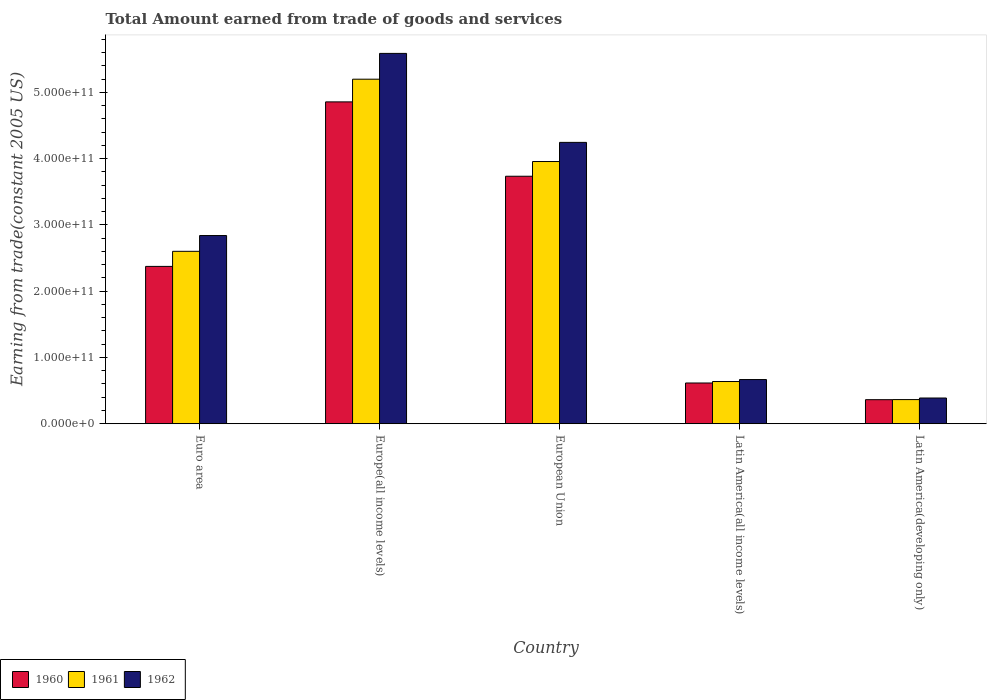How many different coloured bars are there?
Provide a short and direct response. 3. How many groups of bars are there?
Ensure brevity in your answer.  5. Are the number of bars on each tick of the X-axis equal?
Offer a very short reply. Yes. What is the label of the 4th group of bars from the left?
Your answer should be compact. Latin America(all income levels). In how many cases, is the number of bars for a given country not equal to the number of legend labels?
Ensure brevity in your answer.  0. What is the total amount earned by trading goods and services in 1962 in Europe(all income levels)?
Ensure brevity in your answer.  5.59e+11. Across all countries, what is the maximum total amount earned by trading goods and services in 1960?
Provide a short and direct response. 4.86e+11. Across all countries, what is the minimum total amount earned by trading goods and services in 1961?
Provide a short and direct response. 3.64e+1. In which country was the total amount earned by trading goods and services in 1962 maximum?
Give a very brief answer. Europe(all income levels). In which country was the total amount earned by trading goods and services in 1962 minimum?
Keep it short and to the point. Latin America(developing only). What is the total total amount earned by trading goods and services in 1962 in the graph?
Offer a very short reply. 1.37e+12. What is the difference between the total amount earned by trading goods and services in 1961 in Latin America(all income levels) and that in Latin America(developing only)?
Keep it short and to the point. 2.72e+1. What is the difference between the total amount earned by trading goods and services in 1961 in Euro area and the total amount earned by trading goods and services in 1962 in European Union?
Offer a very short reply. -1.64e+11. What is the average total amount earned by trading goods and services in 1962 per country?
Provide a succinct answer. 2.75e+11. What is the difference between the total amount earned by trading goods and services of/in 1961 and total amount earned by trading goods and services of/in 1960 in Latin America(all income levels)?
Keep it short and to the point. 2.22e+09. In how many countries, is the total amount earned by trading goods and services in 1962 greater than 180000000000 US$?
Give a very brief answer. 3. What is the ratio of the total amount earned by trading goods and services in 1962 in Euro area to that in Europe(all income levels)?
Offer a terse response. 0.51. What is the difference between the highest and the second highest total amount earned by trading goods and services in 1962?
Offer a terse response. 1.34e+11. What is the difference between the highest and the lowest total amount earned by trading goods and services in 1961?
Ensure brevity in your answer.  4.83e+11. In how many countries, is the total amount earned by trading goods and services in 1960 greater than the average total amount earned by trading goods and services in 1960 taken over all countries?
Your answer should be very brief. 2. How many bars are there?
Your answer should be very brief. 15. How many countries are there in the graph?
Ensure brevity in your answer.  5. What is the difference between two consecutive major ticks on the Y-axis?
Your answer should be compact. 1.00e+11. Are the values on the major ticks of Y-axis written in scientific E-notation?
Your response must be concise. Yes. Does the graph contain any zero values?
Keep it short and to the point. No. Does the graph contain grids?
Ensure brevity in your answer.  No. Where does the legend appear in the graph?
Keep it short and to the point. Bottom left. How are the legend labels stacked?
Keep it short and to the point. Horizontal. What is the title of the graph?
Keep it short and to the point. Total Amount earned from trade of goods and services. Does "1966" appear as one of the legend labels in the graph?
Provide a short and direct response. No. What is the label or title of the X-axis?
Offer a very short reply. Country. What is the label or title of the Y-axis?
Offer a terse response. Earning from trade(constant 2005 US). What is the Earning from trade(constant 2005 US) in 1960 in Euro area?
Ensure brevity in your answer.  2.37e+11. What is the Earning from trade(constant 2005 US) in 1961 in Euro area?
Your answer should be compact. 2.60e+11. What is the Earning from trade(constant 2005 US) in 1962 in Euro area?
Your answer should be compact. 2.84e+11. What is the Earning from trade(constant 2005 US) in 1960 in Europe(all income levels)?
Make the answer very short. 4.86e+11. What is the Earning from trade(constant 2005 US) of 1961 in Europe(all income levels)?
Ensure brevity in your answer.  5.20e+11. What is the Earning from trade(constant 2005 US) in 1962 in Europe(all income levels)?
Keep it short and to the point. 5.59e+11. What is the Earning from trade(constant 2005 US) in 1960 in European Union?
Your response must be concise. 3.73e+11. What is the Earning from trade(constant 2005 US) in 1961 in European Union?
Offer a terse response. 3.96e+11. What is the Earning from trade(constant 2005 US) of 1962 in European Union?
Offer a terse response. 4.24e+11. What is the Earning from trade(constant 2005 US) in 1960 in Latin America(all income levels)?
Ensure brevity in your answer.  6.15e+1. What is the Earning from trade(constant 2005 US) in 1961 in Latin America(all income levels)?
Offer a very short reply. 6.37e+1. What is the Earning from trade(constant 2005 US) of 1962 in Latin America(all income levels)?
Ensure brevity in your answer.  6.67e+1. What is the Earning from trade(constant 2005 US) in 1960 in Latin America(developing only)?
Your answer should be compact. 3.63e+1. What is the Earning from trade(constant 2005 US) of 1961 in Latin America(developing only)?
Provide a succinct answer. 3.64e+1. What is the Earning from trade(constant 2005 US) of 1962 in Latin America(developing only)?
Your response must be concise. 3.88e+1. Across all countries, what is the maximum Earning from trade(constant 2005 US) in 1960?
Provide a short and direct response. 4.86e+11. Across all countries, what is the maximum Earning from trade(constant 2005 US) of 1961?
Your answer should be very brief. 5.20e+11. Across all countries, what is the maximum Earning from trade(constant 2005 US) of 1962?
Your answer should be very brief. 5.59e+11. Across all countries, what is the minimum Earning from trade(constant 2005 US) of 1960?
Give a very brief answer. 3.63e+1. Across all countries, what is the minimum Earning from trade(constant 2005 US) in 1961?
Provide a succinct answer. 3.64e+1. Across all countries, what is the minimum Earning from trade(constant 2005 US) in 1962?
Your answer should be compact. 3.88e+1. What is the total Earning from trade(constant 2005 US) in 1960 in the graph?
Offer a very short reply. 1.19e+12. What is the total Earning from trade(constant 2005 US) of 1961 in the graph?
Give a very brief answer. 1.28e+12. What is the total Earning from trade(constant 2005 US) of 1962 in the graph?
Your answer should be compact. 1.37e+12. What is the difference between the Earning from trade(constant 2005 US) of 1960 in Euro area and that in Europe(all income levels)?
Your answer should be very brief. -2.48e+11. What is the difference between the Earning from trade(constant 2005 US) in 1961 in Euro area and that in Europe(all income levels)?
Your answer should be very brief. -2.60e+11. What is the difference between the Earning from trade(constant 2005 US) in 1962 in Euro area and that in Europe(all income levels)?
Offer a terse response. -2.75e+11. What is the difference between the Earning from trade(constant 2005 US) in 1960 in Euro area and that in European Union?
Keep it short and to the point. -1.36e+11. What is the difference between the Earning from trade(constant 2005 US) in 1961 in Euro area and that in European Union?
Ensure brevity in your answer.  -1.35e+11. What is the difference between the Earning from trade(constant 2005 US) in 1962 in Euro area and that in European Union?
Your answer should be very brief. -1.41e+11. What is the difference between the Earning from trade(constant 2005 US) in 1960 in Euro area and that in Latin America(all income levels)?
Your answer should be compact. 1.76e+11. What is the difference between the Earning from trade(constant 2005 US) of 1961 in Euro area and that in Latin America(all income levels)?
Your answer should be compact. 1.96e+11. What is the difference between the Earning from trade(constant 2005 US) of 1962 in Euro area and that in Latin America(all income levels)?
Provide a short and direct response. 2.17e+11. What is the difference between the Earning from trade(constant 2005 US) in 1960 in Euro area and that in Latin America(developing only)?
Offer a terse response. 2.01e+11. What is the difference between the Earning from trade(constant 2005 US) in 1961 in Euro area and that in Latin America(developing only)?
Provide a succinct answer. 2.24e+11. What is the difference between the Earning from trade(constant 2005 US) in 1962 in Euro area and that in Latin America(developing only)?
Your answer should be compact. 2.45e+11. What is the difference between the Earning from trade(constant 2005 US) of 1960 in Europe(all income levels) and that in European Union?
Your answer should be compact. 1.12e+11. What is the difference between the Earning from trade(constant 2005 US) of 1961 in Europe(all income levels) and that in European Union?
Keep it short and to the point. 1.24e+11. What is the difference between the Earning from trade(constant 2005 US) of 1962 in Europe(all income levels) and that in European Union?
Provide a succinct answer. 1.34e+11. What is the difference between the Earning from trade(constant 2005 US) of 1960 in Europe(all income levels) and that in Latin America(all income levels)?
Make the answer very short. 4.24e+11. What is the difference between the Earning from trade(constant 2005 US) in 1961 in Europe(all income levels) and that in Latin America(all income levels)?
Offer a terse response. 4.56e+11. What is the difference between the Earning from trade(constant 2005 US) of 1962 in Europe(all income levels) and that in Latin America(all income levels)?
Offer a very short reply. 4.92e+11. What is the difference between the Earning from trade(constant 2005 US) of 1960 in Europe(all income levels) and that in Latin America(developing only)?
Offer a terse response. 4.49e+11. What is the difference between the Earning from trade(constant 2005 US) in 1961 in Europe(all income levels) and that in Latin America(developing only)?
Offer a very short reply. 4.83e+11. What is the difference between the Earning from trade(constant 2005 US) in 1962 in Europe(all income levels) and that in Latin America(developing only)?
Provide a short and direct response. 5.20e+11. What is the difference between the Earning from trade(constant 2005 US) of 1960 in European Union and that in Latin America(all income levels)?
Offer a terse response. 3.12e+11. What is the difference between the Earning from trade(constant 2005 US) of 1961 in European Union and that in Latin America(all income levels)?
Your response must be concise. 3.32e+11. What is the difference between the Earning from trade(constant 2005 US) in 1962 in European Union and that in Latin America(all income levels)?
Your answer should be compact. 3.58e+11. What is the difference between the Earning from trade(constant 2005 US) in 1960 in European Union and that in Latin America(developing only)?
Give a very brief answer. 3.37e+11. What is the difference between the Earning from trade(constant 2005 US) of 1961 in European Union and that in Latin America(developing only)?
Your response must be concise. 3.59e+11. What is the difference between the Earning from trade(constant 2005 US) of 1962 in European Union and that in Latin America(developing only)?
Provide a succinct answer. 3.86e+11. What is the difference between the Earning from trade(constant 2005 US) of 1960 in Latin America(all income levels) and that in Latin America(developing only)?
Ensure brevity in your answer.  2.52e+1. What is the difference between the Earning from trade(constant 2005 US) in 1961 in Latin America(all income levels) and that in Latin America(developing only)?
Offer a very short reply. 2.72e+1. What is the difference between the Earning from trade(constant 2005 US) of 1962 in Latin America(all income levels) and that in Latin America(developing only)?
Offer a terse response. 2.79e+1. What is the difference between the Earning from trade(constant 2005 US) of 1960 in Euro area and the Earning from trade(constant 2005 US) of 1961 in Europe(all income levels)?
Offer a very short reply. -2.82e+11. What is the difference between the Earning from trade(constant 2005 US) in 1960 in Euro area and the Earning from trade(constant 2005 US) in 1962 in Europe(all income levels)?
Your answer should be very brief. -3.21e+11. What is the difference between the Earning from trade(constant 2005 US) of 1961 in Euro area and the Earning from trade(constant 2005 US) of 1962 in Europe(all income levels)?
Give a very brief answer. -2.99e+11. What is the difference between the Earning from trade(constant 2005 US) of 1960 in Euro area and the Earning from trade(constant 2005 US) of 1961 in European Union?
Offer a terse response. -1.58e+11. What is the difference between the Earning from trade(constant 2005 US) in 1960 in Euro area and the Earning from trade(constant 2005 US) in 1962 in European Union?
Your response must be concise. -1.87e+11. What is the difference between the Earning from trade(constant 2005 US) of 1961 in Euro area and the Earning from trade(constant 2005 US) of 1962 in European Union?
Ensure brevity in your answer.  -1.64e+11. What is the difference between the Earning from trade(constant 2005 US) in 1960 in Euro area and the Earning from trade(constant 2005 US) in 1961 in Latin America(all income levels)?
Offer a terse response. 1.74e+11. What is the difference between the Earning from trade(constant 2005 US) in 1960 in Euro area and the Earning from trade(constant 2005 US) in 1962 in Latin America(all income levels)?
Your answer should be very brief. 1.71e+11. What is the difference between the Earning from trade(constant 2005 US) in 1961 in Euro area and the Earning from trade(constant 2005 US) in 1962 in Latin America(all income levels)?
Provide a succinct answer. 1.93e+11. What is the difference between the Earning from trade(constant 2005 US) of 1960 in Euro area and the Earning from trade(constant 2005 US) of 1961 in Latin America(developing only)?
Provide a short and direct response. 2.01e+11. What is the difference between the Earning from trade(constant 2005 US) of 1960 in Euro area and the Earning from trade(constant 2005 US) of 1962 in Latin America(developing only)?
Offer a terse response. 1.99e+11. What is the difference between the Earning from trade(constant 2005 US) of 1961 in Euro area and the Earning from trade(constant 2005 US) of 1962 in Latin America(developing only)?
Offer a very short reply. 2.21e+11. What is the difference between the Earning from trade(constant 2005 US) of 1960 in Europe(all income levels) and the Earning from trade(constant 2005 US) of 1961 in European Union?
Your answer should be very brief. 9.00e+1. What is the difference between the Earning from trade(constant 2005 US) in 1960 in Europe(all income levels) and the Earning from trade(constant 2005 US) in 1962 in European Union?
Your answer should be very brief. 6.11e+1. What is the difference between the Earning from trade(constant 2005 US) in 1961 in Europe(all income levels) and the Earning from trade(constant 2005 US) in 1962 in European Union?
Give a very brief answer. 9.53e+1. What is the difference between the Earning from trade(constant 2005 US) of 1960 in Europe(all income levels) and the Earning from trade(constant 2005 US) of 1961 in Latin America(all income levels)?
Make the answer very short. 4.22e+11. What is the difference between the Earning from trade(constant 2005 US) in 1960 in Europe(all income levels) and the Earning from trade(constant 2005 US) in 1962 in Latin America(all income levels)?
Give a very brief answer. 4.19e+11. What is the difference between the Earning from trade(constant 2005 US) of 1961 in Europe(all income levels) and the Earning from trade(constant 2005 US) of 1962 in Latin America(all income levels)?
Your answer should be very brief. 4.53e+11. What is the difference between the Earning from trade(constant 2005 US) of 1960 in Europe(all income levels) and the Earning from trade(constant 2005 US) of 1961 in Latin America(developing only)?
Provide a short and direct response. 4.49e+11. What is the difference between the Earning from trade(constant 2005 US) in 1960 in Europe(all income levels) and the Earning from trade(constant 2005 US) in 1962 in Latin America(developing only)?
Make the answer very short. 4.47e+11. What is the difference between the Earning from trade(constant 2005 US) of 1961 in Europe(all income levels) and the Earning from trade(constant 2005 US) of 1962 in Latin America(developing only)?
Ensure brevity in your answer.  4.81e+11. What is the difference between the Earning from trade(constant 2005 US) of 1960 in European Union and the Earning from trade(constant 2005 US) of 1961 in Latin America(all income levels)?
Your answer should be very brief. 3.10e+11. What is the difference between the Earning from trade(constant 2005 US) of 1960 in European Union and the Earning from trade(constant 2005 US) of 1962 in Latin America(all income levels)?
Make the answer very short. 3.07e+11. What is the difference between the Earning from trade(constant 2005 US) in 1961 in European Union and the Earning from trade(constant 2005 US) in 1962 in Latin America(all income levels)?
Provide a succinct answer. 3.29e+11. What is the difference between the Earning from trade(constant 2005 US) in 1960 in European Union and the Earning from trade(constant 2005 US) in 1961 in Latin America(developing only)?
Keep it short and to the point. 3.37e+11. What is the difference between the Earning from trade(constant 2005 US) of 1960 in European Union and the Earning from trade(constant 2005 US) of 1962 in Latin America(developing only)?
Give a very brief answer. 3.35e+11. What is the difference between the Earning from trade(constant 2005 US) of 1961 in European Union and the Earning from trade(constant 2005 US) of 1962 in Latin America(developing only)?
Give a very brief answer. 3.57e+11. What is the difference between the Earning from trade(constant 2005 US) in 1960 in Latin America(all income levels) and the Earning from trade(constant 2005 US) in 1961 in Latin America(developing only)?
Provide a succinct answer. 2.50e+1. What is the difference between the Earning from trade(constant 2005 US) of 1960 in Latin America(all income levels) and the Earning from trade(constant 2005 US) of 1962 in Latin America(developing only)?
Your answer should be very brief. 2.27e+1. What is the difference between the Earning from trade(constant 2005 US) in 1961 in Latin America(all income levels) and the Earning from trade(constant 2005 US) in 1962 in Latin America(developing only)?
Provide a succinct answer. 2.49e+1. What is the average Earning from trade(constant 2005 US) of 1960 per country?
Provide a short and direct response. 2.39e+11. What is the average Earning from trade(constant 2005 US) in 1961 per country?
Your answer should be very brief. 2.55e+11. What is the average Earning from trade(constant 2005 US) in 1962 per country?
Your response must be concise. 2.75e+11. What is the difference between the Earning from trade(constant 2005 US) in 1960 and Earning from trade(constant 2005 US) in 1961 in Euro area?
Your answer should be very brief. -2.27e+1. What is the difference between the Earning from trade(constant 2005 US) in 1960 and Earning from trade(constant 2005 US) in 1962 in Euro area?
Your response must be concise. -4.66e+1. What is the difference between the Earning from trade(constant 2005 US) in 1961 and Earning from trade(constant 2005 US) in 1962 in Euro area?
Keep it short and to the point. -2.38e+1. What is the difference between the Earning from trade(constant 2005 US) of 1960 and Earning from trade(constant 2005 US) of 1961 in Europe(all income levels)?
Your response must be concise. -3.42e+1. What is the difference between the Earning from trade(constant 2005 US) in 1960 and Earning from trade(constant 2005 US) in 1962 in Europe(all income levels)?
Your response must be concise. -7.32e+1. What is the difference between the Earning from trade(constant 2005 US) in 1961 and Earning from trade(constant 2005 US) in 1962 in Europe(all income levels)?
Offer a very short reply. -3.89e+1. What is the difference between the Earning from trade(constant 2005 US) of 1960 and Earning from trade(constant 2005 US) of 1961 in European Union?
Keep it short and to the point. -2.22e+1. What is the difference between the Earning from trade(constant 2005 US) in 1960 and Earning from trade(constant 2005 US) in 1962 in European Union?
Ensure brevity in your answer.  -5.11e+1. What is the difference between the Earning from trade(constant 2005 US) of 1961 and Earning from trade(constant 2005 US) of 1962 in European Union?
Your answer should be very brief. -2.89e+1. What is the difference between the Earning from trade(constant 2005 US) of 1960 and Earning from trade(constant 2005 US) of 1961 in Latin America(all income levels)?
Your answer should be compact. -2.22e+09. What is the difference between the Earning from trade(constant 2005 US) of 1960 and Earning from trade(constant 2005 US) of 1962 in Latin America(all income levels)?
Keep it short and to the point. -5.20e+09. What is the difference between the Earning from trade(constant 2005 US) of 1961 and Earning from trade(constant 2005 US) of 1962 in Latin America(all income levels)?
Provide a succinct answer. -2.97e+09. What is the difference between the Earning from trade(constant 2005 US) in 1960 and Earning from trade(constant 2005 US) in 1961 in Latin America(developing only)?
Your response must be concise. -1.49e+08. What is the difference between the Earning from trade(constant 2005 US) of 1960 and Earning from trade(constant 2005 US) of 1962 in Latin America(developing only)?
Make the answer very short. -2.52e+09. What is the difference between the Earning from trade(constant 2005 US) in 1961 and Earning from trade(constant 2005 US) in 1962 in Latin America(developing only)?
Offer a terse response. -2.37e+09. What is the ratio of the Earning from trade(constant 2005 US) of 1960 in Euro area to that in Europe(all income levels)?
Your answer should be very brief. 0.49. What is the ratio of the Earning from trade(constant 2005 US) in 1961 in Euro area to that in Europe(all income levels)?
Offer a very short reply. 0.5. What is the ratio of the Earning from trade(constant 2005 US) of 1962 in Euro area to that in Europe(all income levels)?
Make the answer very short. 0.51. What is the ratio of the Earning from trade(constant 2005 US) in 1960 in Euro area to that in European Union?
Offer a terse response. 0.64. What is the ratio of the Earning from trade(constant 2005 US) of 1961 in Euro area to that in European Union?
Make the answer very short. 0.66. What is the ratio of the Earning from trade(constant 2005 US) of 1962 in Euro area to that in European Union?
Your response must be concise. 0.67. What is the ratio of the Earning from trade(constant 2005 US) of 1960 in Euro area to that in Latin America(all income levels)?
Keep it short and to the point. 3.86. What is the ratio of the Earning from trade(constant 2005 US) in 1961 in Euro area to that in Latin America(all income levels)?
Ensure brevity in your answer.  4.08. What is the ratio of the Earning from trade(constant 2005 US) in 1962 in Euro area to that in Latin America(all income levels)?
Offer a very short reply. 4.26. What is the ratio of the Earning from trade(constant 2005 US) of 1960 in Euro area to that in Latin America(developing only)?
Offer a terse response. 6.54. What is the ratio of the Earning from trade(constant 2005 US) of 1961 in Euro area to that in Latin America(developing only)?
Offer a very short reply. 7.14. What is the ratio of the Earning from trade(constant 2005 US) of 1962 in Euro area to that in Latin America(developing only)?
Provide a short and direct response. 7.32. What is the ratio of the Earning from trade(constant 2005 US) in 1960 in Europe(all income levels) to that in European Union?
Provide a succinct answer. 1.3. What is the ratio of the Earning from trade(constant 2005 US) of 1961 in Europe(all income levels) to that in European Union?
Your response must be concise. 1.31. What is the ratio of the Earning from trade(constant 2005 US) in 1962 in Europe(all income levels) to that in European Union?
Provide a succinct answer. 1.32. What is the ratio of the Earning from trade(constant 2005 US) in 1960 in Europe(all income levels) to that in Latin America(all income levels)?
Your response must be concise. 7.9. What is the ratio of the Earning from trade(constant 2005 US) in 1961 in Europe(all income levels) to that in Latin America(all income levels)?
Keep it short and to the point. 8.16. What is the ratio of the Earning from trade(constant 2005 US) in 1962 in Europe(all income levels) to that in Latin America(all income levels)?
Ensure brevity in your answer.  8.38. What is the ratio of the Earning from trade(constant 2005 US) in 1960 in Europe(all income levels) to that in Latin America(developing only)?
Your answer should be very brief. 13.38. What is the ratio of the Earning from trade(constant 2005 US) in 1961 in Europe(all income levels) to that in Latin America(developing only)?
Your response must be concise. 14.26. What is the ratio of the Earning from trade(constant 2005 US) of 1962 in Europe(all income levels) to that in Latin America(developing only)?
Your response must be concise. 14.39. What is the ratio of the Earning from trade(constant 2005 US) in 1960 in European Union to that in Latin America(all income levels)?
Your answer should be compact. 6.07. What is the ratio of the Earning from trade(constant 2005 US) in 1961 in European Union to that in Latin America(all income levels)?
Your answer should be compact. 6.21. What is the ratio of the Earning from trade(constant 2005 US) of 1962 in European Union to that in Latin America(all income levels)?
Keep it short and to the point. 6.37. What is the ratio of the Earning from trade(constant 2005 US) of 1960 in European Union to that in Latin America(developing only)?
Give a very brief answer. 10.29. What is the ratio of the Earning from trade(constant 2005 US) of 1961 in European Union to that in Latin America(developing only)?
Keep it short and to the point. 10.85. What is the ratio of the Earning from trade(constant 2005 US) of 1962 in European Union to that in Latin America(developing only)?
Your response must be concise. 10.94. What is the ratio of the Earning from trade(constant 2005 US) of 1960 in Latin America(all income levels) to that in Latin America(developing only)?
Your response must be concise. 1.69. What is the ratio of the Earning from trade(constant 2005 US) in 1961 in Latin America(all income levels) to that in Latin America(developing only)?
Give a very brief answer. 1.75. What is the ratio of the Earning from trade(constant 2005 US) of 1962 in Latin America(all income levels) to that in Latin America(developing only)?
Provide a short and direct response. 1.72. What is the difference between the highest and the second highest Earning from trade(constant 2005 US) of 1960?
Ensure brevity in your answer.  1.12e+11. What is the difference between the highest and the second highest Earning from trade(constant 2005 US) in 1961?
Ensure brevity in your answer.  1.24e+11. What is the difference between the highest and the second highest Earning from trade(constant 2005 US) in 1962?
Provide a succinct answer. 1.34e+11. What is the difference between the highest and the lowest Earning from trade(constant 2005 US) of 1960?
Offer a terse response. 4.49e+11. What is the difference between the highest and the lowest Earning from trade(constant 2005 US) in 1961?
Your response must be concise. 4.83e+11. What is the difference between the highest and the lowest Earning from trade(constant 2005 US) in 1962?
Your answer should be compact. 5.20e+11. 